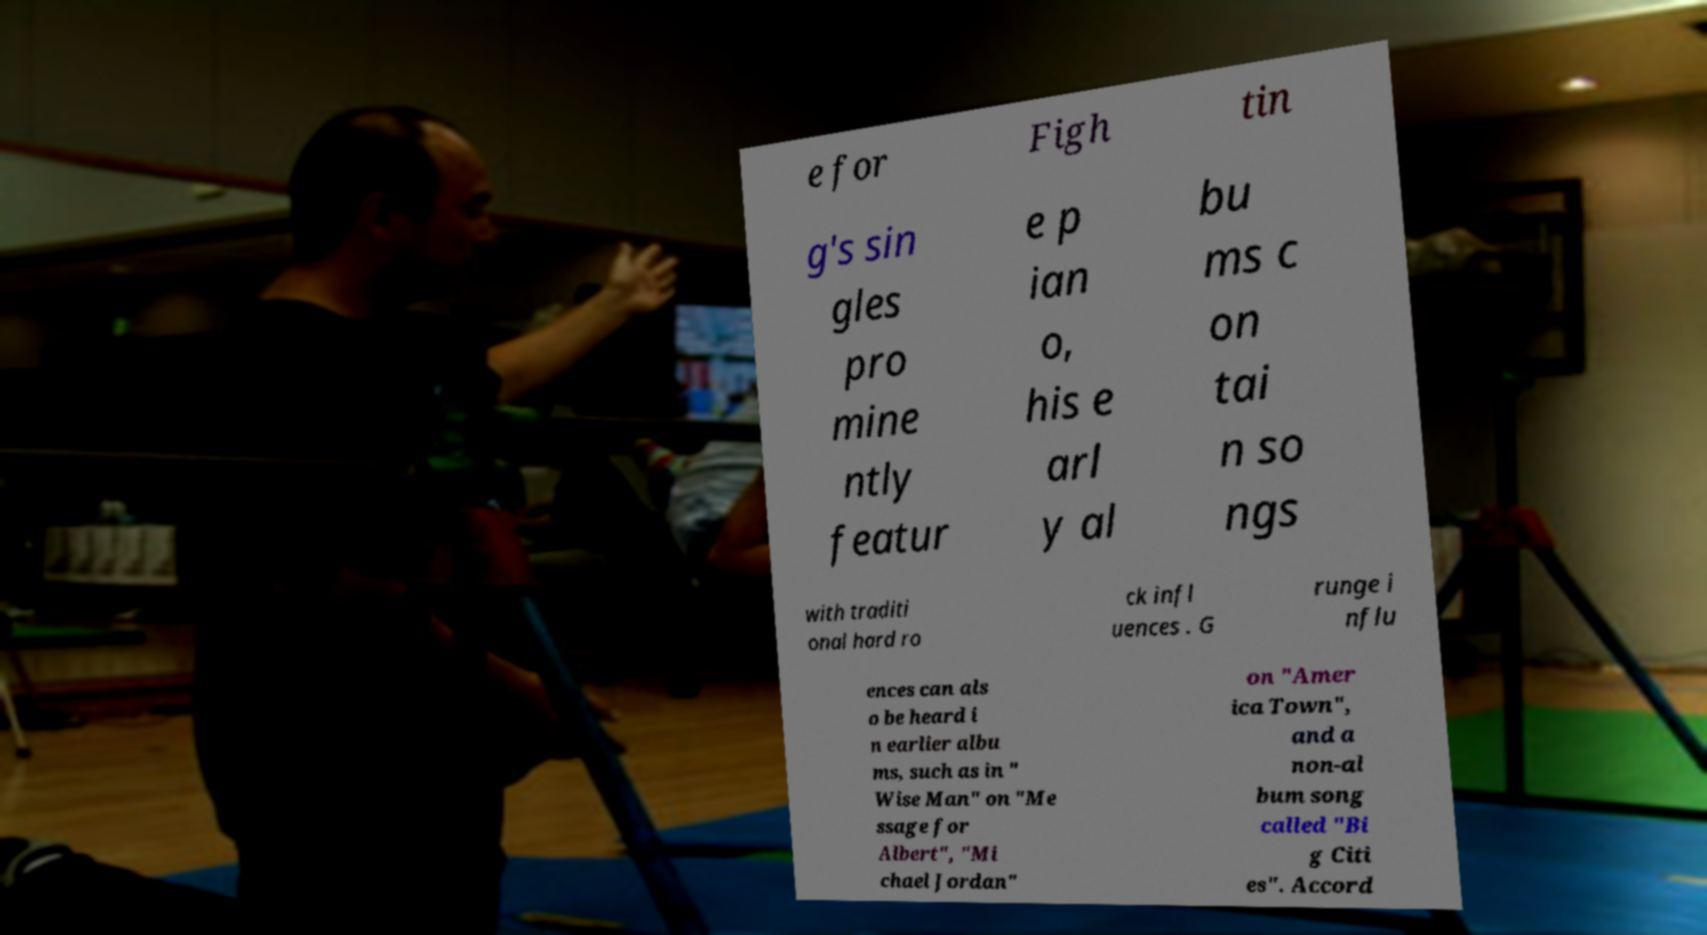I need the written content from this picture converted into text. Can you do that? e for Figh tin g's sin gles pro mine ntly featur e p ian o, his e arl y al bu ms c on tai n so ngs with traditi onal hard ro ck infl uences . G runge i nflu ences can als o be heard i n earlier albu ms, such as in " Wise Man" on "Me ssage for Albert", "Mi chael Jordan" on "Amer ica Town", and a non-al bum song called "Bi g Citi es". Accord 